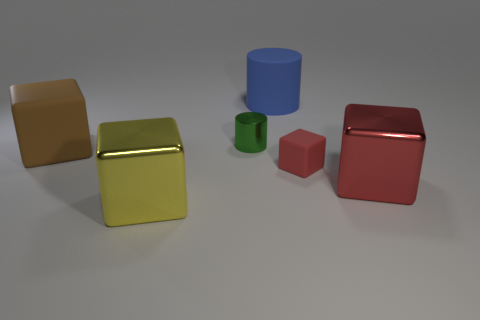What size is the green metal cylinder?
Give a very brief answer. Small. There is a block that is the same color as the small matte object; what is its material?
Offer a very short reply. Metal. What is the color of the large metallic cube that is on the right side of the large matte object behind the brown matte cube?
Your response must be concise. Red. There is a block that is in front of the small red rubber object and on the left side of the large blue rubber cylinder; what is its size?
Give a very brief answer. Large. What number of other things are the same shape as the small green metallic thing?
Ensure brevity in your answer.  1. Do the blue matte object and the big object in front of the red metal cube have the same shape?
Provide a short and direct response. No. What number of big objects are left of the yellow metal thing?
Provide a succinct answer. 1. There is a small thing on the left side of the small red object; is it the same shape as the yellow metal thing?
Your answer should be compact. No. What color is the matte block to the right of the brown matte object?
Your answer should be very brief. Red. There is a green thing that is the same material as the large red block; what is its shape?
Provide a succinct answer. Cylinder. 